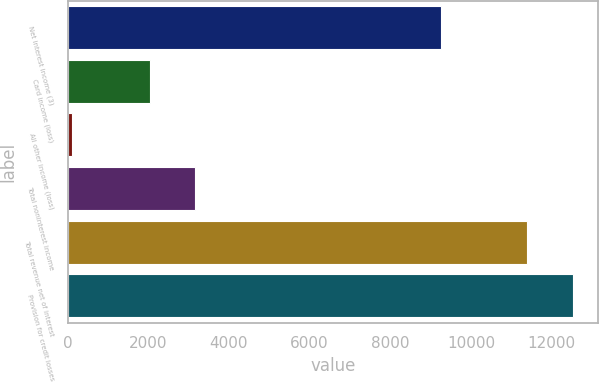Convert chart to OTSL. <chart><loc_0><loc_0><loc_500><loc_500><bar_chart><fcel>Net interest income (3)<fcel>Card income (loss)<fcel>All other income (loss)<fcel>Total noninterest income<fcel>Total revenue net of interest<fcel>Provision for credit losses<nl><fcel>9250<fcel>2034<fcel>115<fcel>3162.4<fcel>11399<fcel>12527.4<nl></chart> 